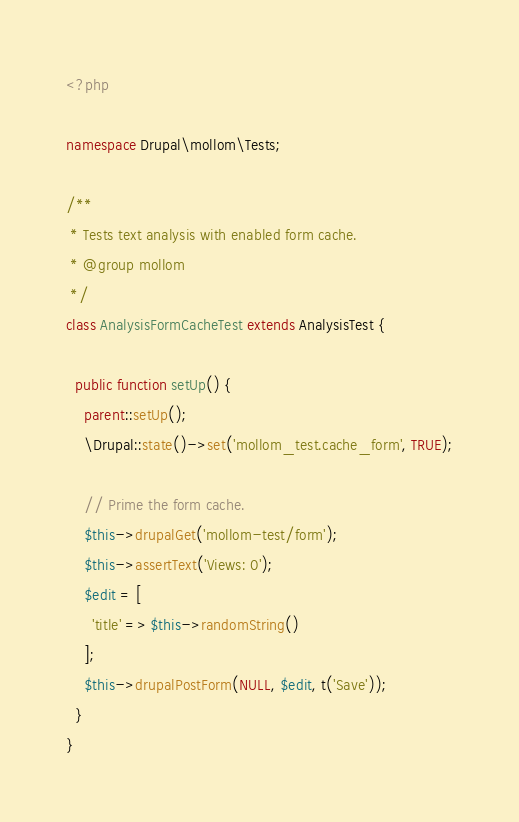Convert code to text. <code><loc_0><loc_0><loc_500><loc_500><_PHP_><?php

namespace Drupal\mollom\Tests;

/**
 * Tests text analysis with enabled form cache.
 * @group mollom
 */
class AnalysisFormCacheTest extends AnalysisTest {

  public function setUp() {
    parent::setUp();
    \Drupal::state()->set('mollom_test.cache_form', TRUE);

    // Prime the form cache.
    $this->drupalGet('mollom-test/form');
    $this->assertText('Views: 0');
    $edit = [
      'title' => $this->randomString()
    ];
    $this->drupalPostForm(NULL, $edit, t('Save'));
  }
}
</code> 